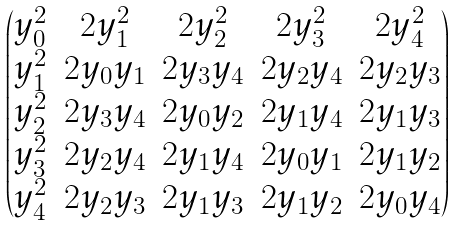<formula> <loc_0><loc_0><loc_500><loc_500>\begin{pmatrix} y _ { 0 } ^ { 2 } & 2 y _ { 1 } ^ { 2 } & 2 y _ { 2 } ^ { 2 } & 2 y _ { 3 } ^ { 2 } & 2 y _ { 4 } ^ { 2 } \\ y _ { 1 } ^ { 2 } & 2 y _ { 0 } y _ { 1 } & 2 y _ { 3 } y _ { 4 } & 2 y _ { 2 } y _ { 4 } & 2 y _ { 2 } y _ { 3 } \\ y _ { 2 } ^ { 2 } & 2 y _ { 3 } y _ { 4 } & 2 y _ { 0 } y _ { 2 } & 2 y _ { 1 } y _ { 4 } & 2 y _ { 1 } y _ { 3 } \\ y _ { 3 } ^ { 2 } & 2 y _ { 2 } y _ { 4 } & 2 y _ { 1 } y _ { 4 } & 2 y _ { 0 } y _ { 1 } & 2 y _ { 1 } y _ { 2 } \\ y _ { 4 } ^ { 2 } & 2 y _ { 2 } y _ { 3 } & 2 y _ { 1 } y _ { 3 } & 2 y _ { 1 } y _ { 2 } & 2 y _ { 0 } y _ { 4 } \end{pmatrix}</formula> 